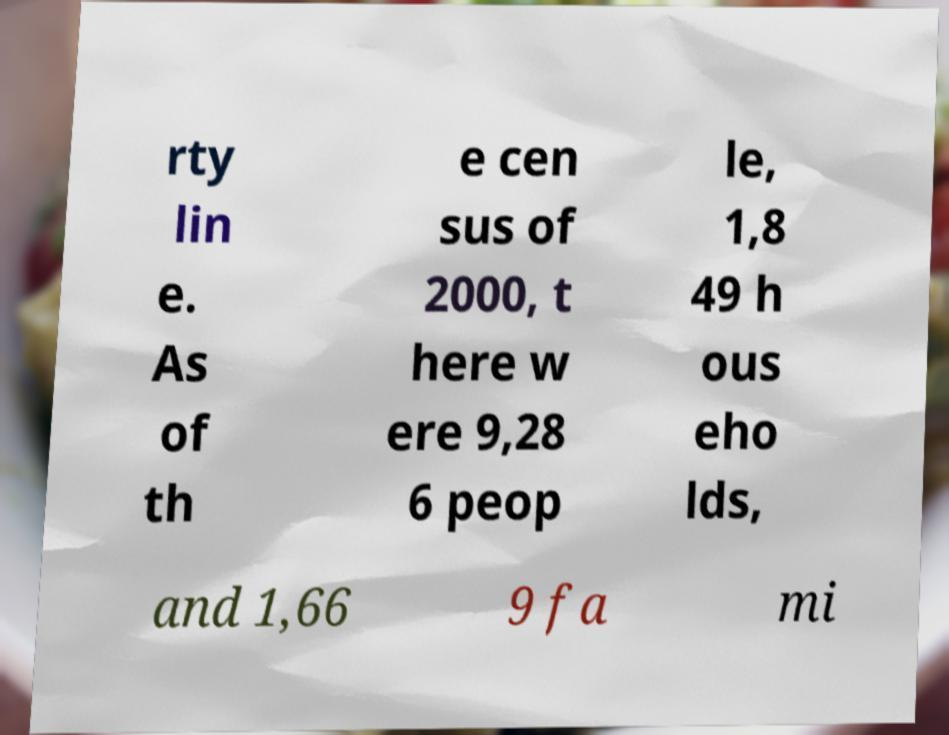Could you assist in decoding the text presented in this image and type it out clearly? rty lin e. As of th e cen sus of 2000, t here w ere 9,28 6 peop le, 1,8 49 h ous eho lds, and 1,66 9 fa mi 